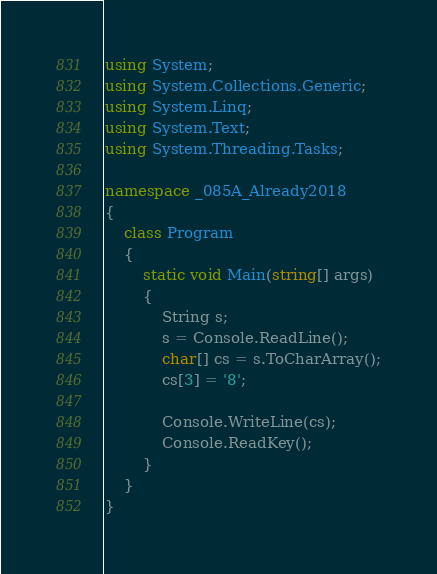Convert code to text. <code><loc_0><loc_0><loc_500><loc_500><_C#_>using System;
using System.Collections.Generic;
using System.Linq;
using System.Text;
using System.Threading.Tasks;

namespace _085A_Already2018
{
    class Program
    {
        static void Main(string[] args)
        {
            String s;
            s = Console.ReadLine();
            char[] cs = s.ToCharArray();
            cs[3] = '8';

            Console.WriteLine(cs);
            Console.ReadKey();
        }
    }
}
</code> 